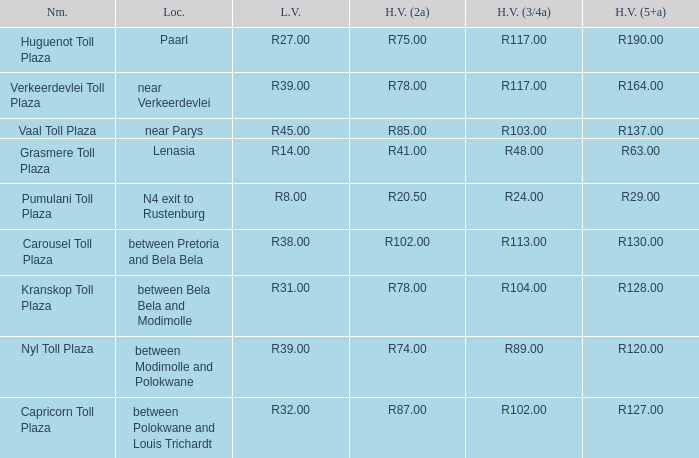What is the place of the carousel toll plaza? Between pretoria and bela bela. 